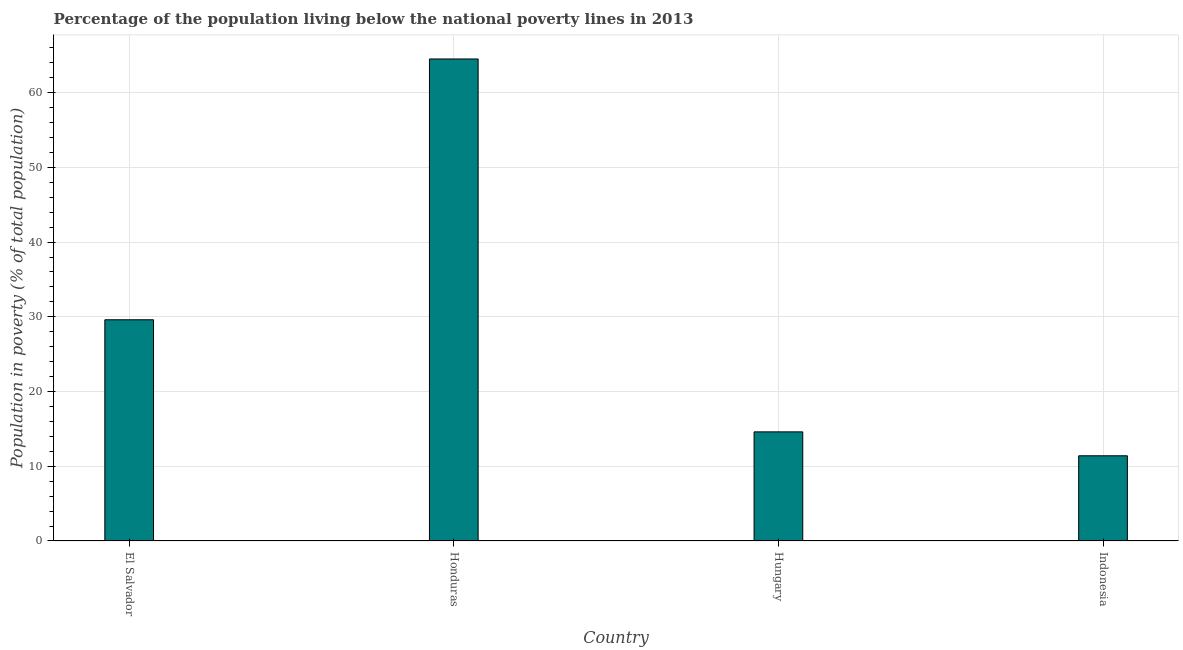What is the title of the graph?
Your response must be concise. Percentage of the population living below the national poverty lines in 2013. What is the label or title of the X-axis?
Provide a short and direct response. Country. What is the label or title of the Y-axis?
Keep it short and to the point. Population in poverty (% of total population). What is the percentage of population living below poverty line in Honduras?
Give a very brief answer. 64.5. Across all countries, what is the maximum percentage of population living below poverty line?
Offer a terse response. 64.5. Across all countries, what is the minimum percentage of population living below poverty line?
Keep it short and to the point. 11.4. In which country was the percentage of population living below poverty line maximum?
Your response must be concise. Honduras. What is the sum of the percentage of population living below poverty line?
Your response must be concise. 120.1. What is the average percentage of population living below poverty line per country?
Give a very brief answer. 30.02. What is the median percentage of population living below poverty line?
Offer a terse response. 22.1. What is the ratio of the percentage of population living below poverty line in Honduras to that in Hungary?
Offer a very short reply. 4.42. Is the difference between the percentage of population living below poverty line in El Salvador and Hungary greater than the difference between any two countries?
Ensure brevity in your answer.  No. What is the difference between the highest and the second highest percentage of population living below poverty line?
Offer a terse response. 34.9. Is the sum of the percentage of population living below poverty line in El Salvador and Honduras greater than the maximum percentage of population living below poverty line across all countries?
Provide a short and direct response. Yes. What is the difference between the highest and the lowest percentage of population living below poverty line?
Offer a terse response. 53.1. In how many countries, is the percentage of population living below poverty line greater than the average percentage of population living below poverty line taken over all countries?
Offer a terse response. 1. How many countries are there in the graph?
Make the answer very short. 4. What is the Population in poverty (% of total population) of El Salvador?
Provide a succinct answer. 29.6. What is the Population in poverty (% of total population) in Honduras?
Ensure brevity in your answer.  64.5. What is the difference between the Population in poverty (% of total population) in El Salvador and Honduras?
Your answer should be compact. -34.9. What is the difference between the Population in poverty (% of total population) in El Salvador and Indonesia?
Provide a succinct answer. 18.2. What is the difference between the Population in poverty (% of total population) in Honduras and Hungary?
Your response must be concise. 49.9. What is the difference between the Population in poverty (% of total population) in Honduras and Indonesia?
Your response must be concise. 53.1. What is the difference between the Population in poverty (% of total population) in Hungary and Indonesia?
Offer a very short reply. 3.2. What is the ratio of the Population in poverty (% of total population) in El Salvador to that in Honduras?
Offer a terse response. 0.46. What is the ratio of the Population in poverty (% of total population) in El Salvador to that in Hungary?
Provide a short and direct response. 2.03. What is the ratio of the Population in poverty (% of total population) in El Salvador to that in Indonesia?
Provide a succinct answer. 2.6. What is the ratio of the Population in poverty (% of total population) in Honduras to that in Hungary?
Provide a succinct answer. 4.42. What is the ratio of the Population in poverty (% of total population) in Honduras to that in Indonesia?
Your answer should be compact. 5.66. What is the ratio of the Population in poverty (% of total population) in Hungary to that in Indonesia?
Keep it short and to the point. 1.28. 